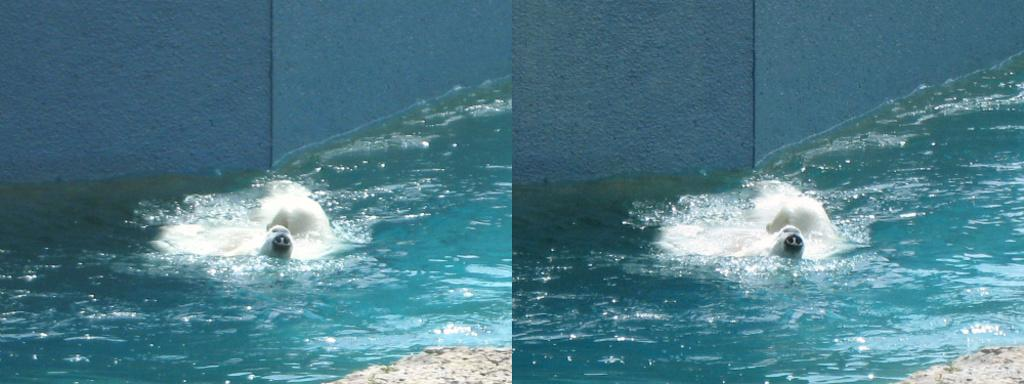What is the composition of the image? The image is a collage of same images. What natural element is visible in the image? There is water visible in the image. What type of animal can be seen in the water? There is an animal in the water. What can be seen in the background of the image? There is a wall in the background of the image. Can you see a rifle being used by the animal in the image? There is no rifle present in the image, nor is there any indication of the animal using one. 